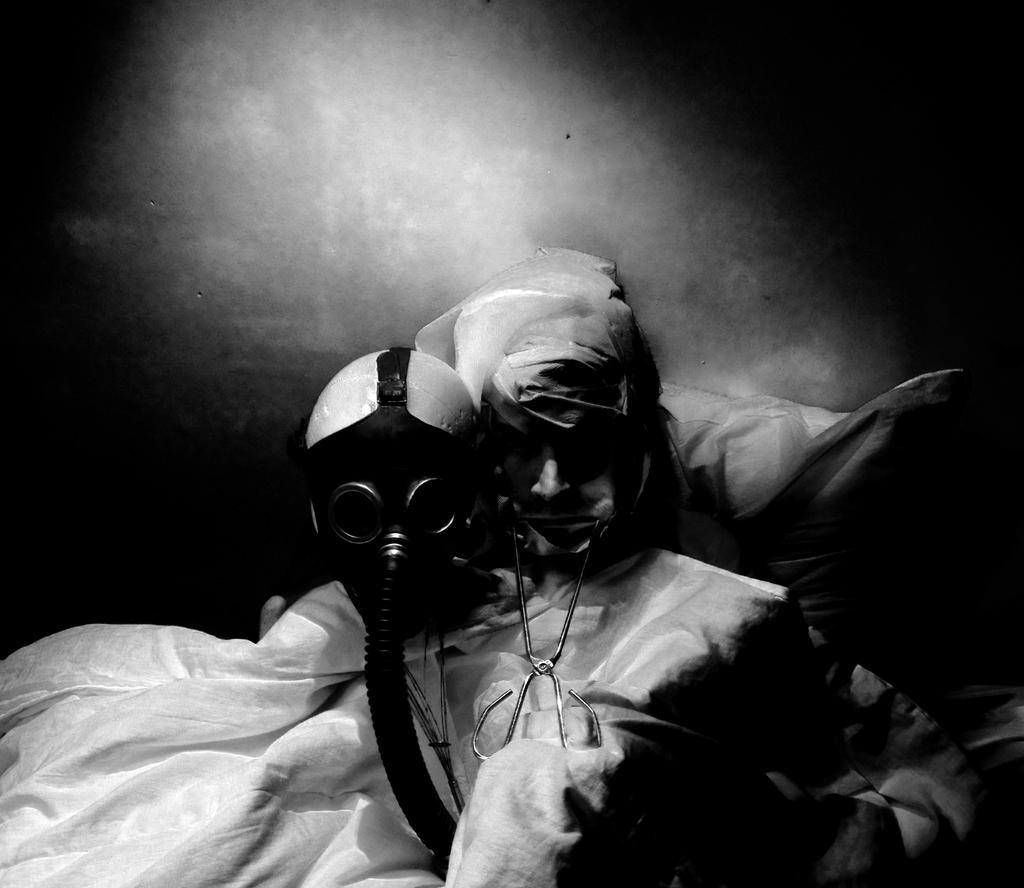Could you give a brief overview of what you see in this image? In this picture we can observe a person wearing a white color dress. There is a mask which is in black color and we can observe black color tube fixed to this mask. This person is holding a dental instrument in his mouth. Behind him there is a pillow. The background is in white and black color. 